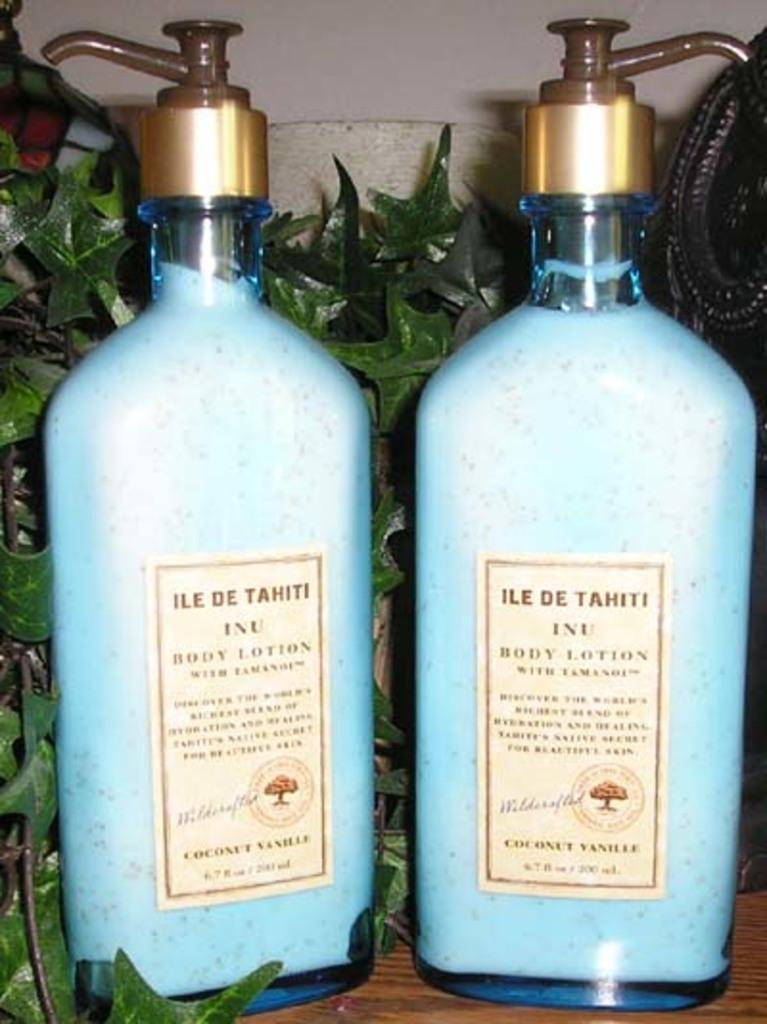How many blue color bottles are in the image? There are two blue color bottles in the image. What else can be seen in the image besides the bottles? There is a plant and other objects in the image. What is written on the bottles? The writing on the bottles is not specified in the facts. Is there a turkey roaming around in the image? No, there is no turkey present in the image. What is the plot of the story being told in the image? The image does not depict a story or plot; it is a still image of bottles and a plant. 